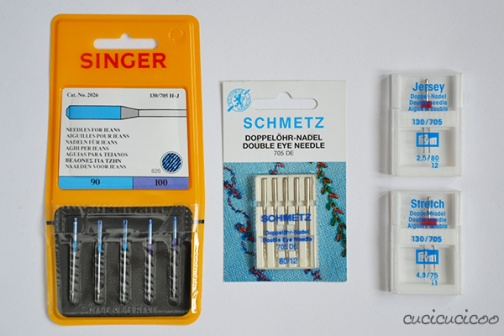Can you explain how the double needles from Schmetz are used versus traditional single needles? Double needles, as seen in the Schmetz package, are unique because they have two needle points on a single shank, allowing for two parallel rows of stitches using one machine pass. This is especially useful for creating professional-looking hemlines or adding decorative topstitching. In contrast, traditional single needles create one line of stitching and are used for a broader range of general sewing tasks. 